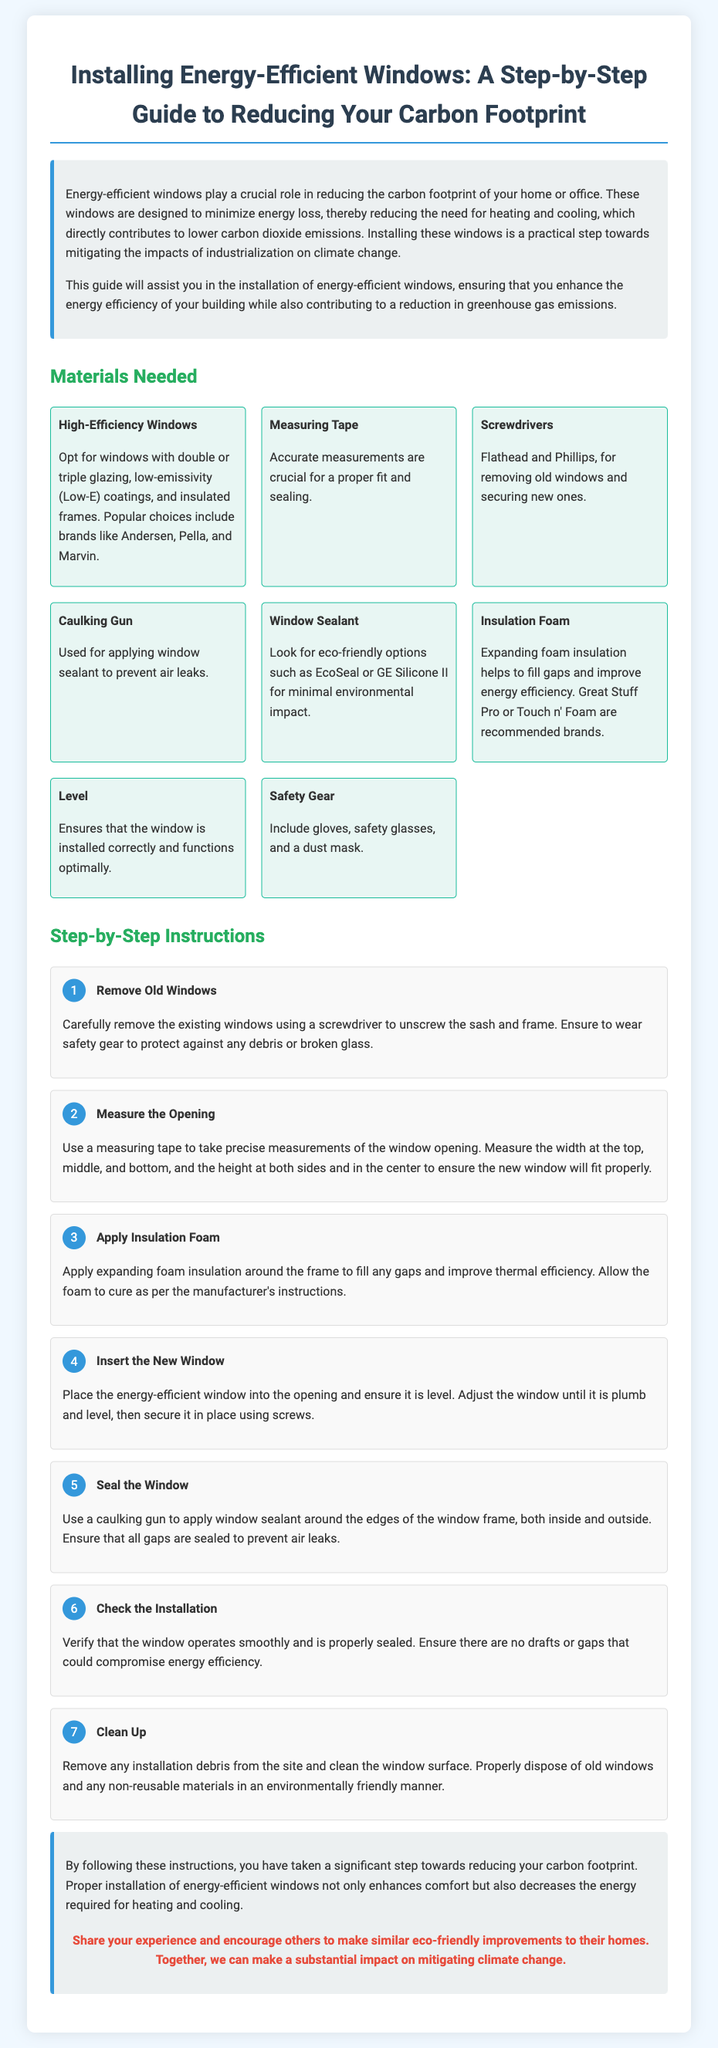What is the title of the guide? The title of the guide is found in the header section of the document, which states, "Installing Energy-Efficient Windows: A Step-by-Step Guide to Reducing Your Carbon Footprint."
Answer: Installing Energy-Efficient Windows: A Step-by-Step Guide to Reducing Your Carbon Footprint Which material is used to fill gaps around the window frame? The document mentions "Expanding foam insulation" as the material used for this purpose, specifically noting the importance of improving thermal efficiency.
Answer: Expanding foam insulation How many steps are there in the installation process? The document lists a total of seven distinct steps in the section under "Step-by-Step Instructions."
Answer: 7 What is the first step in the installation process? The first step, as detailed in the instructions, is to "Remove Old Windows," indicating the first action needed in the process.
Answer: Remove Old Windows What is the purpose of using a caulking gun in the installation? The document explains that the caulking gun is used to "apply window sealant around the edges of the window frame" to prevent air leaks.
Answer: Apply window sealant Which brand is recommended for window sealant? The document provides examples of eco-friendly options, specifically mentioning "EcoSeal" or "GE Silicone II" as recommended brands.
Answer: EcoSeal or GE Silicone II What should be checked after installing the window? The instructions suggest verifying that the window "operates smoothly and is properly sealed" to ensure there are no drafts or gaps compromising energy efficiency.
Answer: Operates smoothly and is properly sealed What is the call to action at the end of the document? The conclusion includes a call to action that encourages readers to share their experience and make similar eco-friendly improvements.
Answer: Share your experience and encourage others to make similar eco-friendly improvements to their homes 